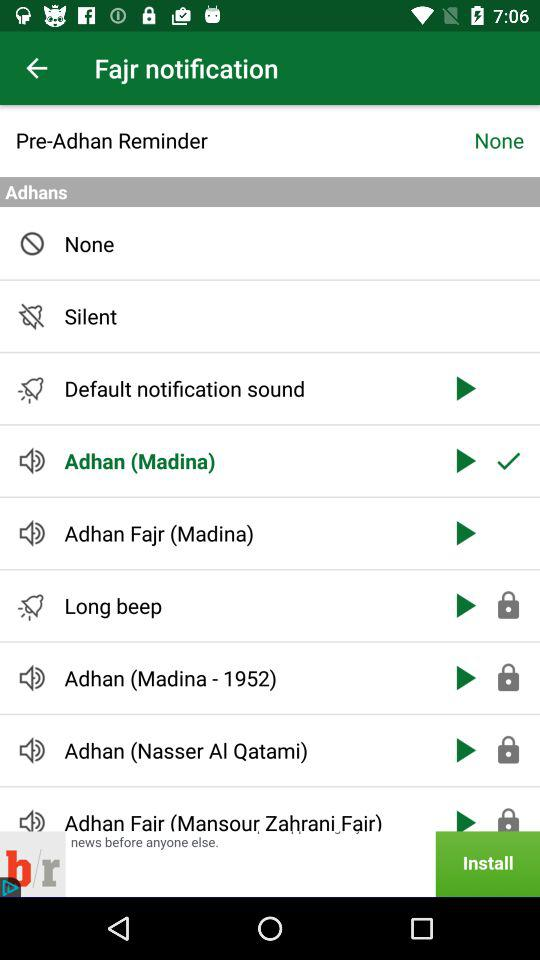Which option is selected in "Adhans"? The selected option in "Adhans" is "Adhan (Madina)". 